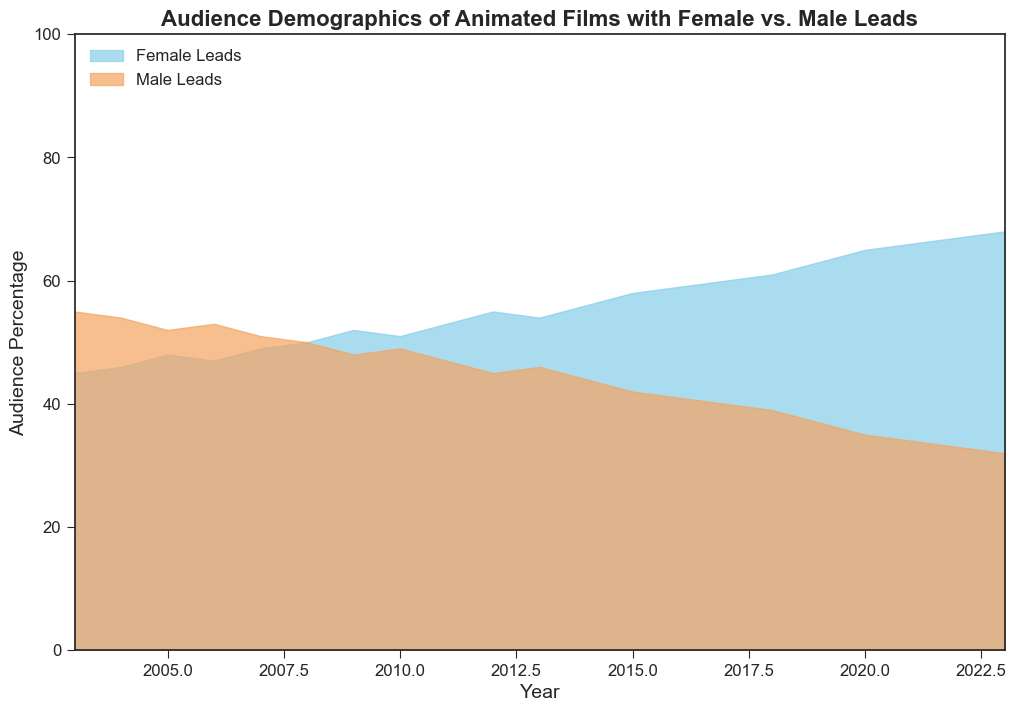What is the trend of the audience percentage for animated films with female leads from 2003 to 2023? To answer this question, observe the line and colored area representing female leads in the chart. It starts lower in 2003 and steadily increases over time, indicating a positive trend.
Answer: Increasing In which year did the percentage of audiences for animated films with female leads exceed those with male leads? Look for the intersection point on the chart where the two areas cross. This occurs around the year where the switch happens, which is visually noticeable in the plot.
Answer: 2008 By how much did the audience percentage for films with female leads increase from 2003 to 2023? Compare the audience percentage for female leads in 2003 with that in 2023 and calculate the difference. The percentage in 2003 was 45%, and in 2023 it was 68%. So, 68% - 45% = 23%.
Answer: 23% What's the median audience percentage for animated films with male leads over the entire period? List the percentages and find the middle value since we have 21 data points. The middle value is at the 11th position when sorted: 47%
Answer: 47% Compare the audience percentages for animated films with female leads in 2010 and 2020. Which year had a higher percentage? Check the chart for the percentages corresponding to the years 2010 and 2020 for female leads. 2010 has 51%, and 2020 has 65%, so 2020 is higher.
Answer: 2020 What is the average audience percentage for films with male leads from 2015 to 2023? Sum the percentages for 2015 to 2023 and divide by the number of years (9). (42 + 41 + 40 + 39+ 37 + 35 + 34 + 33 + 32) / 9 = 293 / 9 = approximately 32.56
Answer: 32.56 At what rate did the audience percentage for female leads grow per year on average from 2003 to 2023? Calculate the difference between the percentages in 2023 and 2003 and divide by the number of years, 20. (68-45) / 20 = 23 / 20 ≈ 1.15%
Answer: 1.15% Which year had the closest audience percentage between films with female leads and male leads? Identify the year where the two audience percentages are most similar or equal. In 2008, both are exactly 50%.
Answer: 2008 